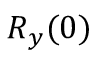<formula> <loc_0><loc_0><loc_500><loc_500>R _ { y } ( 0 )</formula> 